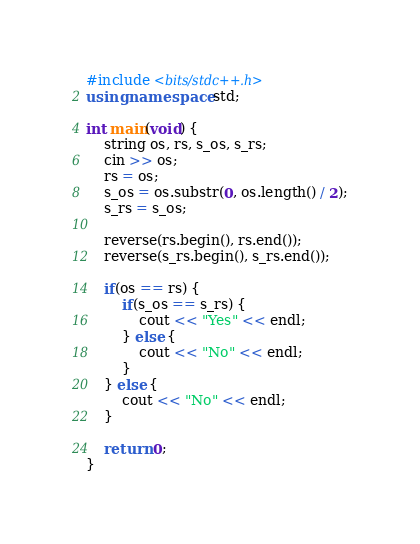<code> <loc_0><loc_0><loc_500><loc_500><_C++_>#include <bits/stdc++.h>
using namespace std;

int main(void) {
    string os, rs, s_os, s_rs;
    cin >> os;
    rs = os;
    s_os = os.substr(0, os.length() / 2);
    s_rs = s_os;

    reverse(rs.begin(), rs.end());
    reverse(s_rs.begin(), s_rs.end());

    if(os == rs) {
        if(s_os == s_rs) {
            cout << "Yes" << endl;
        } else {
            cout << "No" << endl;
        }
    } else {
        cout << "No" << endl;
    }

    return 0;
}</code> 